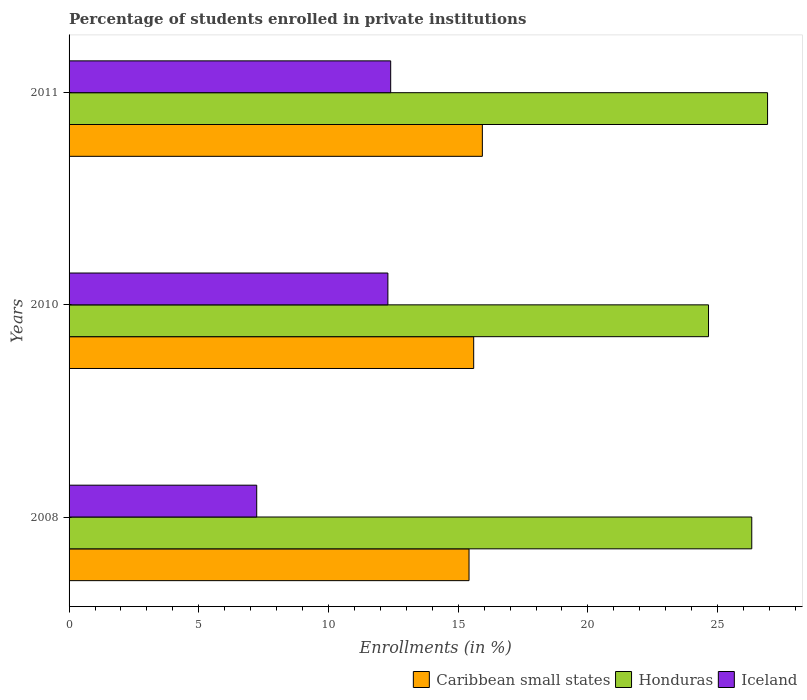How many different coloured bars are there?
Offer a very short reply. 3. How many bars are there on the 3rd tick from the bottom?
Your response must be concise. 3. What is the label of the 3rd group of bars from the top?
Provide a short and direct response. 2008. In how many cases, is the number of bars for a given year not equal to the number of legend labels?
Your answer should be compact. 0. What is the percentage of trained teachers in Iceland in 2011?
Make the answer very short. 12.4. Across all years, what is the maximum percentage of trained teachers in Caribbean small states?
Keep it short and to the point. 15.93. Across all years, what is the minimum percentage of trained teachers in Caribbean small states?
Your answer should be compact. 15.42. What is the total percentage of trained teachers in Iceland in the graph?
Provide a short and direct response. 31.92. What is the difference between the percentage of trained teachers in Honduras in 2008 and that in 2010?
Make the answer very short. 1.67. What is the difference between the percentage of trained teachers in Iceland in 2010 and the percentage of trained teachers in Caribbean small states in 2008?
Provide a succinct answer. -3.13. What is the average percentage of trained teachers in Caribbean small states per year?
Keep it short and to the point. 15.65. In the year 2011, what is the difference between the percentage of trained teachers in Caribbean small states and percentage of trained teachers in Iceland?
Make the answer very short. 3.53. In how many years, is the percentage of trained teachers in Honduras greater than 25 %?
Provide a short and direct response. 2. What is the ratio of the percentage of trained teachers in Caribbean small states in 2010 to that in 2011?
Make the answer very short. 0.98. Is the difference between the percentage of trained teachers in Caribbean small states in 2008 and 2011 greater than the difference between the percentage of trained teachers in Iceland in 2008 and 2011?
Your answer should be compact. Yes. What is the difference between the highest and the second highest percentage of trained teachers in Honduras?
Your answer should be compact. 0.61. What is the difference between the highest and the lowest percentage of trained teachers in Iceland?
Give a very brief answer. 5.16. Is the sum of the percentage of trained teachers in Iceland in 2010 and 2011 greater than the maximum percentage of trained teachers in Caribbean small states across all years?
Your response must be concise. Yes. What does the 2nd bar from the top in 2011 represents?
Offer a terse response. Honduras. What does the 1st bar from the bottom in 2008 represents?
Make the answer very short. Caribbean small states. Is it the case that in every year, the sum of the percentage of trained teachers in Honduras and percentage of trained teachers in Caribbean small states is greater than the percentage of trained teachers in Iceland?
Give a very brief answer. Yes. How many bars are there?
Your response must be concise. 9. Are the values on the major ticks of X-axis written in scientific E-notation?
Your answer should be very brief. No. Where does the legend appear in the graph?
Your answer should be very brief. Bottom right. What is the title of the graph?
Your response must be concise. Percentage of students enrolled in private institutions. Does "Finland" appear as one of the legend labels in the graph?
Offer a very short reply. No. What is the label or title of the X-axis?
Provide a succinct answer. Enrollments (in %). What is the label or title of the Y-axis?
Your response must be concise. Years. What is the Enrollments (in %) of Caribbean small states in 2008?
Keep it short and to the point. 15.42. What is the Enrollments (in %) of Honduras in 2008?
Your answer should be compact. 26.32. What is the Enrollments (in %) of Iceland in 2008?
Keep it short and to the point. 7.23. What is the Enrollments (in %) in Caribbean small states in 2010?
Keep it short and to the point. 15.6. What is the Enrollments (in %) of Honduras in 2010?
Keep it short and to the point. 24.65. What is the Enrollments (in %) of Iceland in 2010?
Offer a very short reply. 12.29. What is the Enrollments (in %) in Caribbean small states in 2011?
Make the answer very short. 15.93. What is the Enrollments (in %) of Honduras in 2011?
Offer a very short reply. 26.93. What is the Enrollments (in %) in Iceland in 2011?
Your answer should be very brief. 12.4. Across all years, what is the maximum Enrollments (in %) in Caribbean small states?
Your response must be concise. 15.93. Across all years, what is the maximum Enrollments (in %) in Honduras?
Your answer should be very brief. 26.93. Across all years, what is the maximum Enrollments (in %) of Iceland?
Ensure brevity in your answer.  12.4. Across all years, what is the minimum Enrollments (in %) in Caribbean small states?
Keep it short and to the point. 15.42. Across all years, what is the minimum Enrollments (in %) of Honduras?
Your answer should be very brief. 24.65. Across all years, what is the minimum Enrollments (in %) in Iceland?
Offer a terse response. 7.23. What is the total Enrollments (in %) in Caribbean small states in the graph?
Keep it short and to the point. 46.95. What is the total Enrollments (in %) of Honduras in the graph?
Ensure brevity in your answer.  77.89. What is the total Enrollments (in %) of Iceland in the graph?
Your response must be concise. 31.92. What is the difference between the Enrollments (in %) of Caribbean small states in 2008 and that in 2010?
Provide a succinct answer. -0.18. What is the difference between the Enrollments (in %) in Iceland in 2008 and that in 2010?
Offer a very short reply. -5.06. What is the difference between the Enrollments (in %) in Caribbean small states in 2008 and that in 2011?
Your answer should be very brief. -0.51. What is the difference between the Enrollments (in %) of Honduras in 2008 and that in 2011?
Your answer should be compact. -0.61. What is the difference between the Enrollments (in %) of Iceland in 2008 and that in 2011?
Provide a succinct answer. -5.16. What is the difference between the Enrollments (in %) of Caribbean small states in 2010 and that in 2011?
Offer a very short reply. -0.33. What is the difference between the Enrollments (in %) in Honduras in 2010 and that in 2011?
Your response must be concise. -2.28. What is the difference between the Enrollments (in %) in Iceland in 2010 and that in 2011?
Ensure brevity in your answer.  -0.11. What is the difference between the Enrollments (in %) in Caribbean small states in 2008 and the Enrollments (in %) in Honduras in 2010?
Your answer should be compact. -9.23. What is the difference between the Enrollments (in %) of Caribbean small states in 2008 and the Enrollments (in %) of Iceland in 2010?
Give a very brief answer. 3.13. What is the difference between the Enrollments (in %) of Honduras in 2008 and the Enrollments (in %) of Iceland in 2010?
Ensure brevity in your answer.  14.03. What is the difference between the Enrollments (in %) of Caribbean small states in 2008 and the Enrollments (in %) of Honduras in 2011?
Offer a very short reply. -11.51. What is the difference between the Enrollments (in %) of Caribbean small states in 2008 and the Enrollments (in %) of Iceland in 2011?
Ensure brevity in your answer.  3.02. What is the difference between the Enrollments (in %) in Honduras in 2008 and the Enrollments (in %) in Iceland in 2011?
Offer a very short reply. 13.92. What is the difference between the Enrollments (in %) of Caribbean small states in 2010 and the Enrollments (in %) of Honduras in 2011?
Ensure brevity in your answer.  -11.33. What is the difference between the Enrollments (in %) in Caribbean small states in 2010 and the Enrollments (in %) in Iceland in 2011?
Provide a short and direct response. 3.2. What is the difference between the Enrollments (in %) of Honduras in 2010 and the Enrollments (in %) of Iceland in 2011?
Provide a short and direct response. 12.25. What is the average Enrollments (in %) of Caribbean small states per year?
Make the answer very short. 15.65. What is the average Enrollments (in %) in Honduras per year?
Make the answer very short. 25.96. What is the average Enrollments (in %) of Iceland per year?
Offer a terse response. 10.64. In the year 2008, what is the difference between the Enrollments (in %) in Caribbean small states and Enrollments (in %) in Honduras?
Give a very brief answer. -10.9. In the year 2008, what is the difference between the Enrollments (in %) of Caribbean small states and Enrollments (in %) of Iceland?
Offer a terse response. 8.18. In the year 2008, what is the difference between the Enrollments (in %) in Honduras and Enrollments (in %) in Iceland?
Give a very brief answer. 19.08. In the year 2010, what is the difference between the Enrollments (in %) of Caribbean small states and Enrollments (in %) of Honduras?
Provide a succinct answer. -9.05. In the year 2010, what is the difference between the Enrollments (in %) of Caribbean small states and Enrollments (in %) of Iceland?
Keep it short and to the point. 3.31. In the year 2010, what is the difference between the Enrollments (in %) in Honduras and Enrollments (in %) in Iceland?
Your answer should be very brief. 12.36. In the year 2011, what is the difference between the Enrollments (in %) in Caribbean small states and Enrollments (in %) in Honduras?
Your answer should be compact. -10.99. In the year 2011, what is the difference between the Enrollments (in %) of Caribbean small states and Enrollments (in %) of Iceland?
Give a very brief answer. 3.53. In the year 2011, what is the difference between the Enrollments (in %) in Honduras and Enrollments (in %) in Iceland?
Offer a terse response. 14.53. What is the ratio of the Enrollments (in %) of Caribbean small states in 2008 to that in 2010?
Your answer should be compact. 0.99. What is the ratio of the Enrollments (in %) in Honduras in 2008 to that in 2010?
Your answer should be compact. 1.07. What is the ratio of the Enrollments (in %) in Iceland in 2008 to that in 2010?
Your answer should be compact. 0.59. What is the ratio of the Enrollments (in %) of Caribbean small states in 2008 to that in 2011?
Keep it short and to the point. 0.97. What is the ratio of the Enrollments (in %) of Honduras in 2008 to that in 2011?
Make the answer very short. 0.98. What is the ratio of the Enrollments (in %) in Iceland in 2008 to that in 2011?
Provide a succinct answer. 0.58. What is the ratio of the Enrollments (in %) of Honduras in 2010 to that in 2011?
Offer a terse response. 0.92. What is the ratio of the Enrollments (in %) in Iceland in 2010 to that in 2011?
Your answer should be very brief. 0.99. What is the difference between the highest and the second highest Enrollments (in %) of Caribbean small states?
Make the answer very short. 0.33. What is the difference between the highest and the second highest Enrollments (in %) of Honduras?
Provide a succinct answer. 0.61. What is the difference between the highest and the second highest Enrollments (in %) of Iceland?
Give a very brief answer. 0.11. What is the difference between the highest and the lowest Enrollments (in %) in Caribbean small states?
Give a very brief answer. 0.51. What is the difference between the highest and the lowest Enrollments (in %) in Honduras?
Ensure brevity in your answer.  2.28. What is the difference between the highest and the lowest Enrollments (in %) of Iceland?
Offer a terse response. 5.16. 